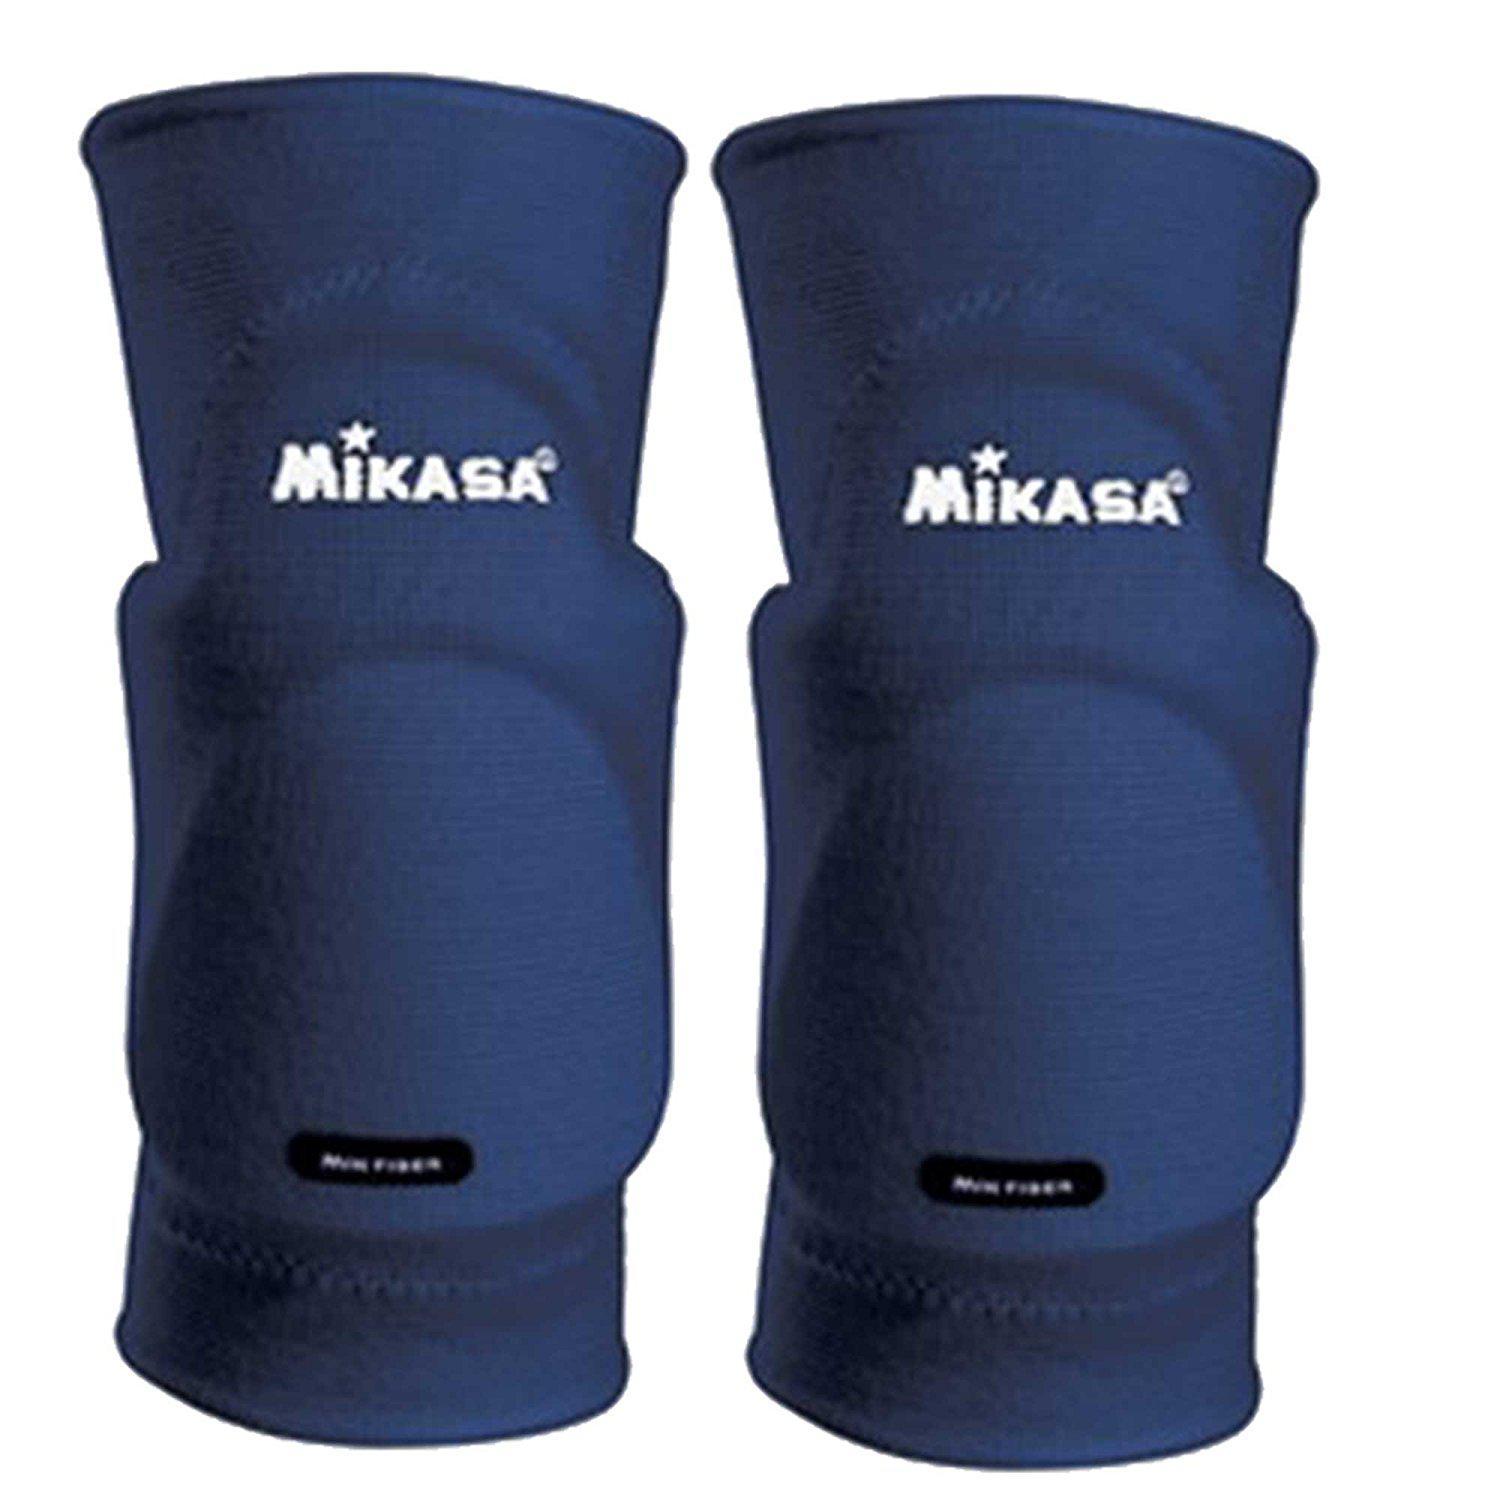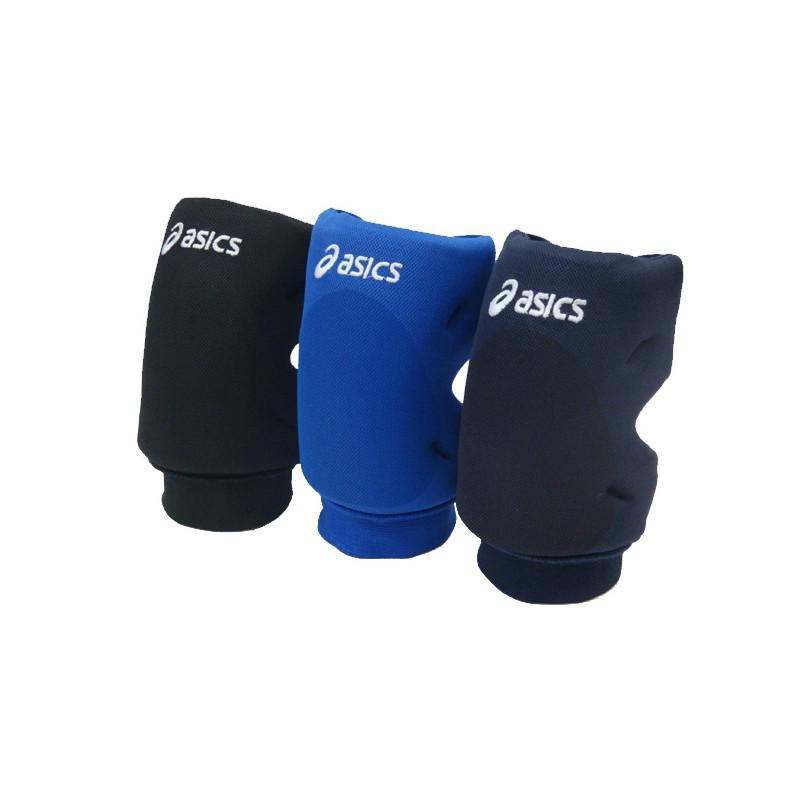The first image is the image on the left, the second image is the image on the right. Assess this claim about the two images: "There are exactly seven knee braces in total.". Correct or not? Answer yes or no. No. The first image is the image on the left, the second image is the image on the right. Given the left and right images, does the statement "There are exactly seven knee pads in total." hold true? Answer yes or no. No. 